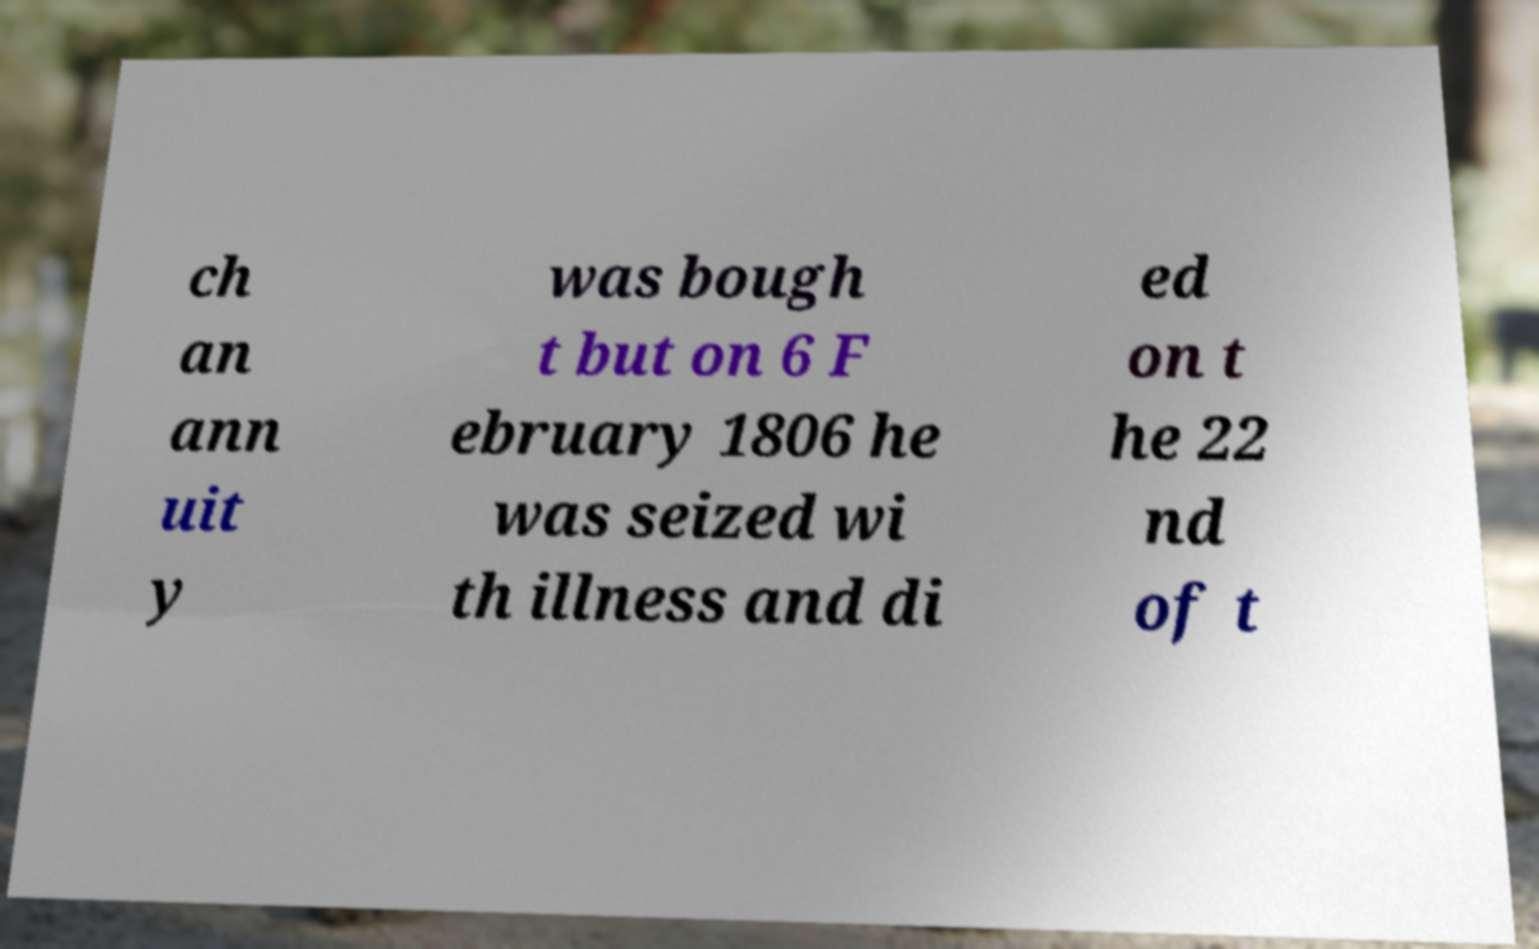Could you extract and type out the text from this image? ch an ann uit y was bough t but on 6 F ebruary 1806 he was seized wi th illness and di ed on t he 22 nd of t 